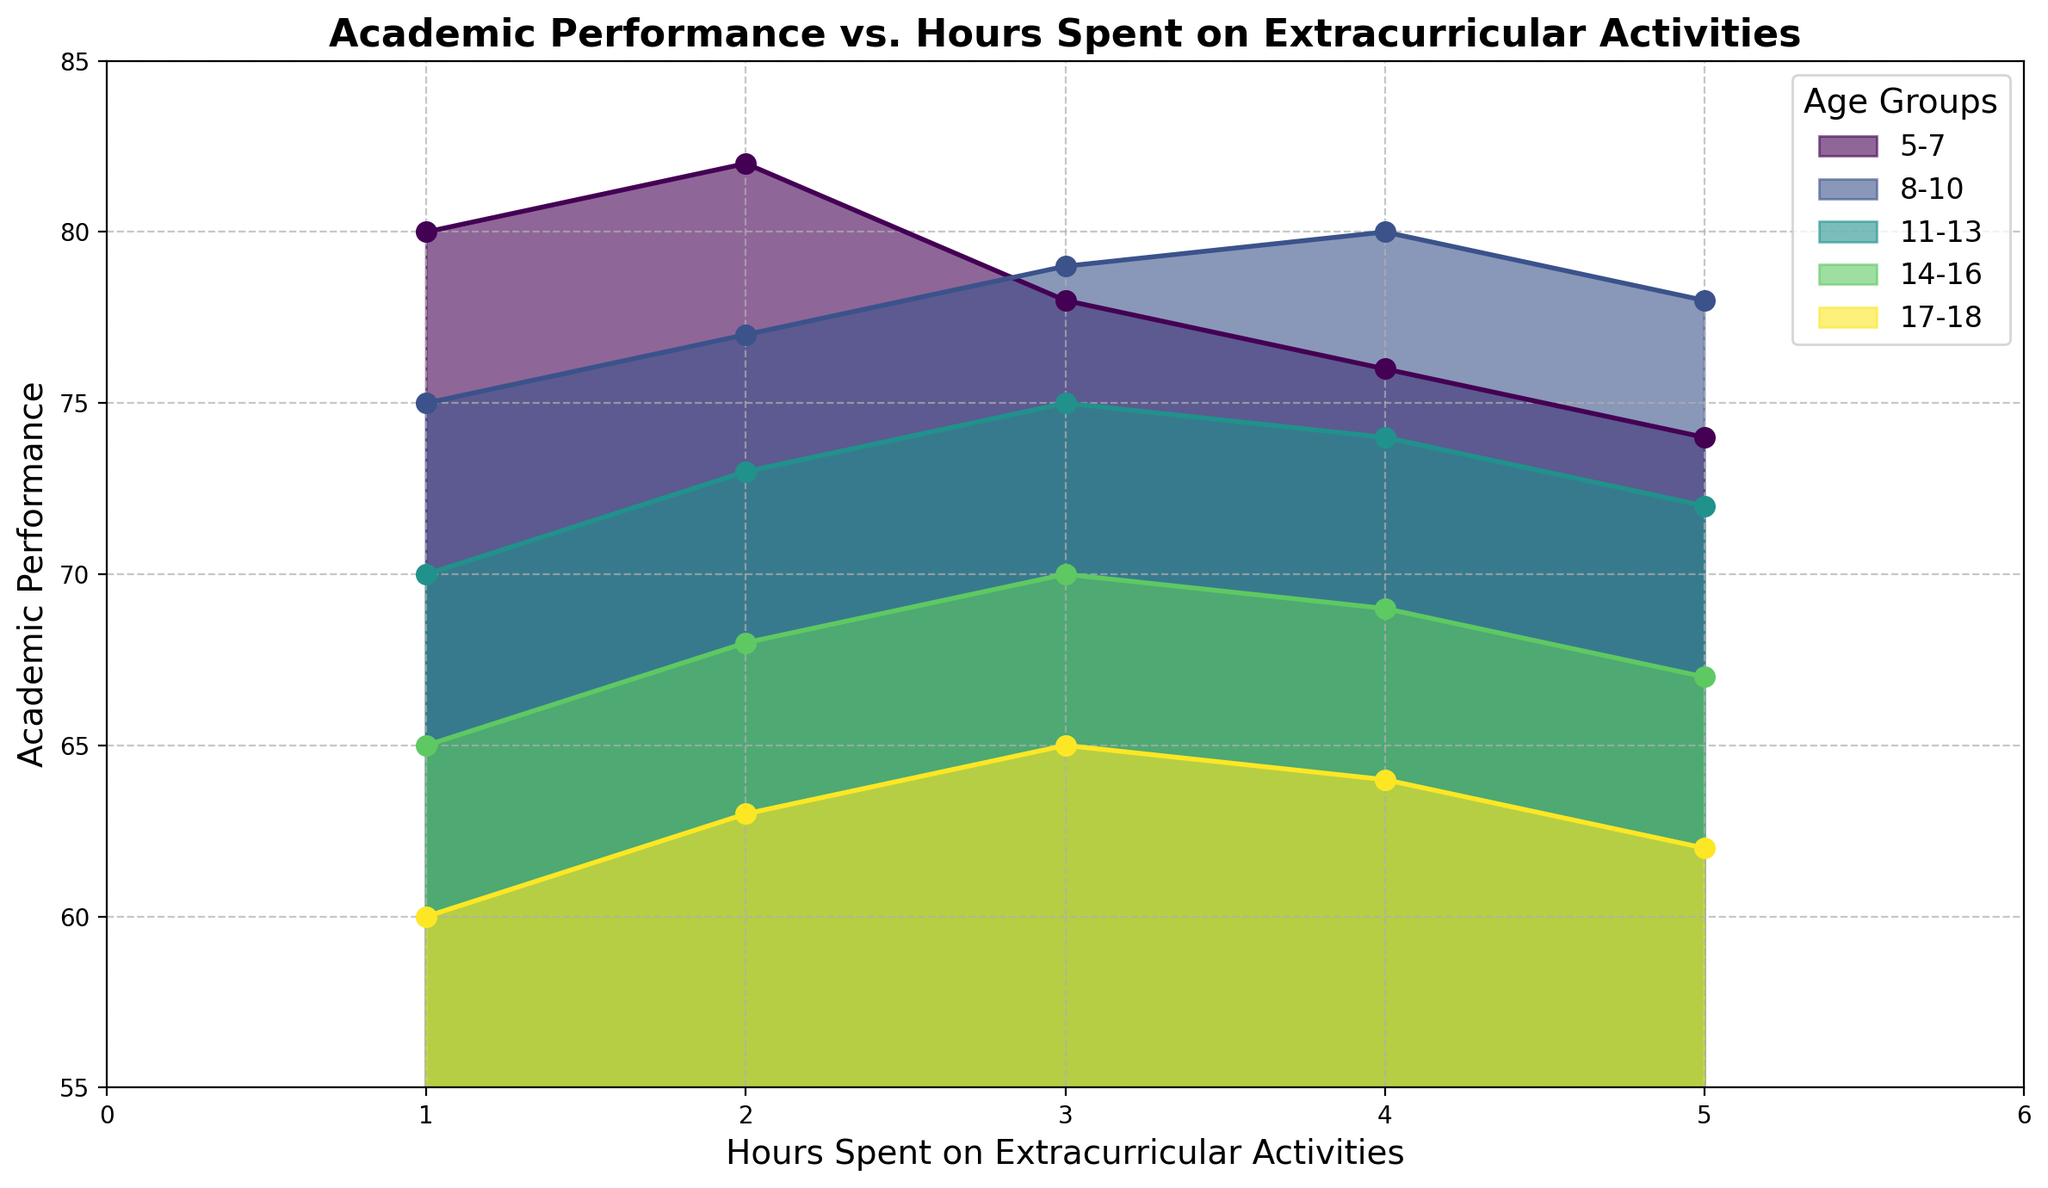What is the average academic performance for the 5-7 age group? First, look at the academic performance values for the 5-7 age group: 80, 82, 78, 76, and 74. Sum these values (80 + 82 + 78 + 76 + 74 = 390) and then divide by the number of data points (390 / 5 = 78)
Answer: 78 Which age group shows the steepest decline in academic performance with an increase in extracurricular hours? Look at the slopes of the lines connecting the points for each age group. The 17-18 age group shows the most significant decline in academic performance as extracurricular hours increase.
Answer: 17-18 What is the academic performance at 3 hours of extracurricular activities for the 8-10 age group? Locate the point corresponding to 3 hours of extracurricular activities for the 8-10 age group. The academic performance at this point is 79.
Answer: 79 How does the academic performance at 1 hour of extracurricular activities compare between the 8-10 and 14-16 age groups? Compare the data points for 1 hour of extracurricular activities for both age groups. The 8-10 age group has an academic performance of 75, whereas the 14-16 age group has 65. Therefore, the 8-10 age group performs better.
Answer: 75 vs 65; 8-10 performs better What is the difference in academic performance between 2 hours and 4 hours of extracurricular activities for the 11-13 age group? Identify the academic performance at 2 hours (73) and 4 hours (74) for the 11-13 age group. The difference is calculated as 74 - 73 = 1.
Answer: 1 Which age group improves their academic performance the most between 1 hour and 2 hours of extracurricular activities? Find the difference in academic performance between 1 hour and 2 hours for each age group. The 17-18 age group shows an increase from 60 to 63, an improvement of 3, which is the highest among all age groups.
Answer: 17-18 Which age group has the highest academic performance at 4 hours of extracurricular activities? Look at the academic performance values for 4 hours of extracurricular activities. The 8-10 age group has the highest performance with a value of 80.
Answer: 8-10 Does any age group show an increase in academic performance as extracurricular hours increase from 4 to 5 hours? Look for an increase in academic performance between 4 and 5 hours for each age group. None of the age groups show an increase; all either remain the same or decrease.
Answer: No age group What is the trend in academic performance for the 14-16 age group as extracurricular hours increase? Observe the line for the 14-16 age group. It generally shows a downward trend, indicating that academic performance decreases as extracurricular hours increase.
Answer: Decreasing trend What is the academic performance range for the 11-13 and 8-10 age groups? For the 11-13 age group, the lowest performance is 70, and the highest is 75, giving a range of 5. For the 8-10 age group, the lowest is 75 and the highest is 80, giving a range of 5.
Answer: 5 for both 